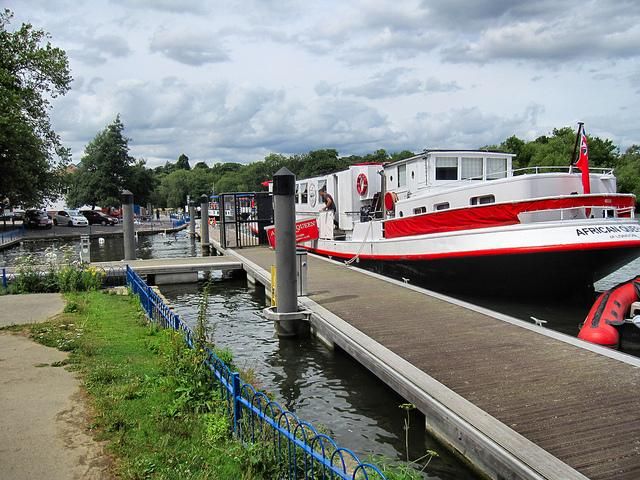What's the term for how this boat is parked? Please explain your reasoning. docked. The term is docked. 